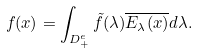<formula> <loc_0><loc_0><loc_500><loc_500>f ( x ) = \int _ { D ^ { e } _ { + } } \tilde { f } ( \lambda ) \overline { E _ { \lambda } ( x ) } d \lambda .</formula> 